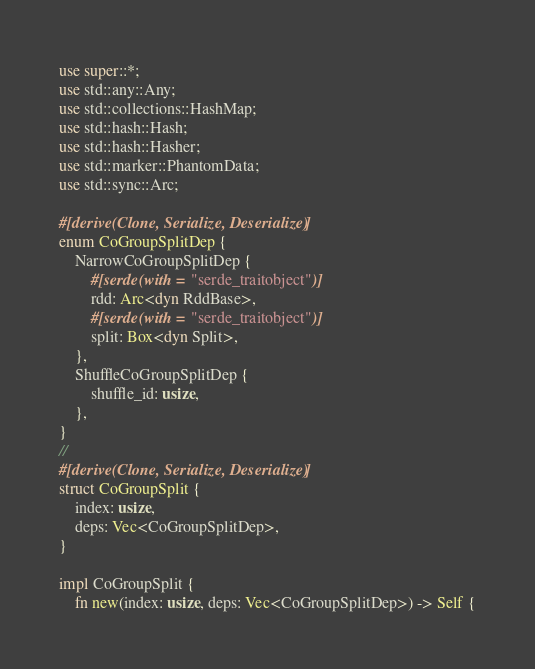Convert code to text. <code><loc_0><loc_0><loc_500><loc_500><_Rust_>use super::*;
use std::any::Any;
use std::collections::HashMap;
use std::hash::Hash;
use std::hash::Hasher;
use std::marker::PhantomData;
use std::sync::Arc;

#[derive(Clone, Serialize, Deserialize)]
enum CoGroupSplitDep {
    NarrowCoGroupSplitDep {
        #[serde(with = "serde_traitobject")]
        rdd: Arc<dyn RddBase>,
        #[serde(with = "serde_traitobject")]
        split: Box<dyn Split>,
    },
    ShuffleCoGroupSplitDep {
        shuffle_id: usize,
    },
}
//
#[derive(Clone, Serialize, Deserialize)]
struct CoGroupSplit {
    index: usize,
    deps: Vec<CoGroupSplitDep>,
}

impl CoGroupSplit {
    fn new(index: usize, deps: Vec<CoGroupSplitDep>) -> Self {</code> 